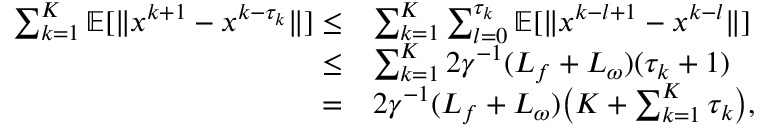Convert formula to latex. <formula><loc_0><loc_0><loc_500><loc_500>\begin{array} { r l } { \sum _ { k = 1 } ^ { K } \mathbb { E } [ \| x ^ { k + 1 } - x ^ { k - \tau _ { k } } \| ] \leq } & { \sum _ { k = 1 } ^ { K } \sum _ { l = 0 } ^ { \tau _ { k } } \mathbb { E } [ \| x ^ { k - l + 1 } - x ^ { k - l } \| ] } \\ { \leq } & { \sum _ { k = 1 } ^ { K } 2 \gamma ^ { - 1 } ( L _ { f } + L _ { \omega } ) ( \tau _ { k } + 1 ) } \\ { = } & { 2 \gamma ^ { - 1 } ( L _ { f } + L _ { \omega } ) \left ( K + \sum _ { k = 1 } ^ { K } \tau _ { k } \right ) , } \end{array}</formula> 